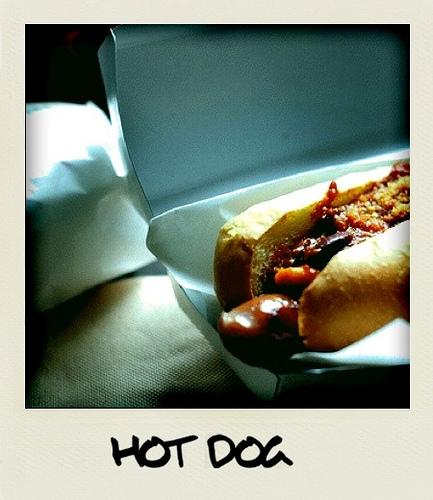What does the writing on the bottom say?
Short answer required. Hot dog. Is this a hot dog?
Concise answer only. Yes. Are there onions on the hot dog?
Give a very brief answer. No. 